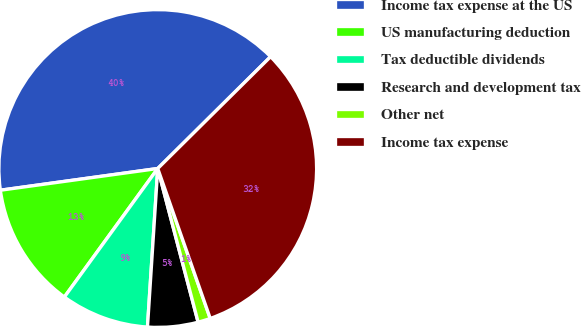Convert chart. <chart><loc_0><loc_0><loc_500><loc_500><pie_chart><fcel>Income tax expense at the US<fcel>US manufacturing deduction<fcel>Tax deductible dividends<fcel>Research and development tax<fcel>Other net<fcel>Income tax expense<nl><fcel>39.76%<fcel>12.82%<fcel>8.97%<fcel>5.12%<fcel>1.27%<fcel>32.07%<nl></chart> 